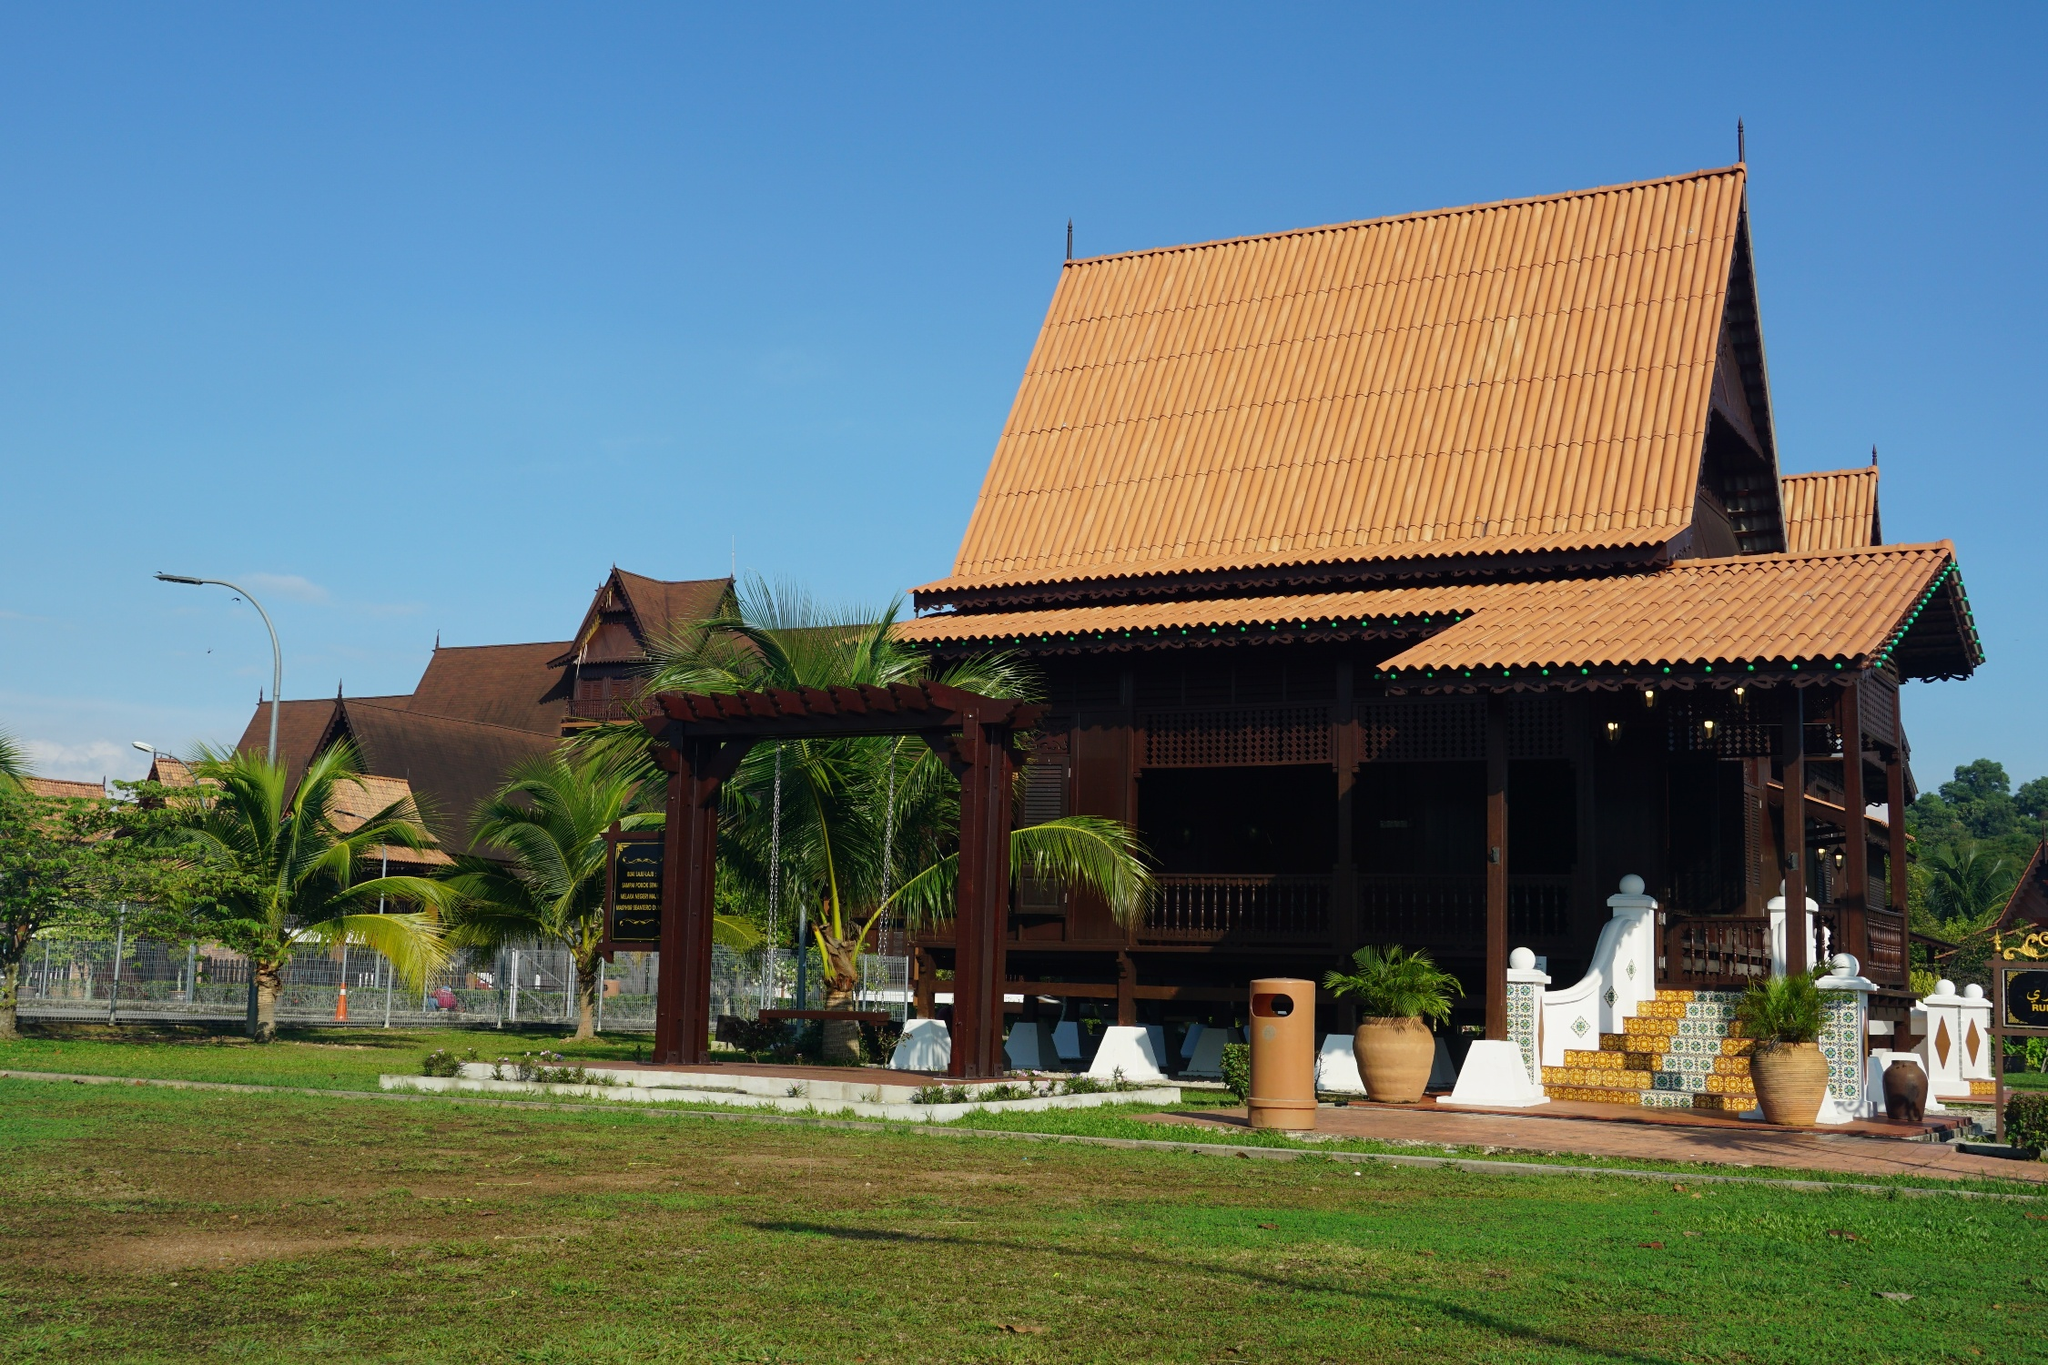If you could spend a day at this location, what would you do? Spending a day at this location would be an absolute delight! I would start my morning by exploring the house, captivated by its architectural beauty and intricate details. After that, I would enjoy a leisurely stroll around the lush garden, admiring the tropical plants and the soothing sounds of nature.

For lunch, I would have a picnic on the pristine lawn, savoring delicious Thai cuisine while basking in the sun and gentle breeze. In the afternoon, I might relax on the porch with a good book, immersing myself in the tranquil environment.

As the day comes to a close, I would take a walk among the swaying palm trees, reflecting on the serene beauty of the setting. The sunset would paint the sky in vibrant hues, creating a perfect ending to a peaceful and refreshing day. How might this house appear in a historical film? In a historical film, this traditional Thai house would serve as a stunning and authentic backdrop, adding depth and realism to the narrative. The film might depict life in a rural village, focusing on the day-to-day activities of its inhabitants. The house's architecture, with its elevated structure and steeply pitched roof, would be central to scenes depicting cultural traditions, family gatherings, and community events.

Intricate wooden carvings would be showcased in moments that highlight Thai craftsmanship, perhaps in a scene where artisans are seen working meticulously on their art. The lush green lawn and surrounding palm trees could serve as settings for key plot points, whether it's a joyous celebration or a poignant moment of reflection. The house, with its rich cultural and historical significance, would enhance the film's authenticity and visual appeal, transporting viewers back in time to experience the beauty and essence of traditional Thai life. What activities might the residents of this house enjoy on a typical day? The residents of this traditional Thai house likely enjoy a variety of activities that connect them with their culture and environment. Their day might begin with a quiet morning ritual, offering prayers and preparing traditional Thai breakfast using fresh, locally sourced ingredients. This is followed by tending to the garden, ensuring the plants are well-cared for amid the tropical ambiance.

In the late morning and afternoon, the family might engage in crafting activities such as weaving or wood carving, reflecting the rich traditions of Thai artistry. Children might play in the spacious lawn, perhaps gathering under the shade of the palm trees for games or stories.

Meals would be a central part of daily life, with everyone coming together to prepare and enjoy dishes that are rich in flavors and heritage. Evenings could be spent on the porch, sharing stories and experiences or simply enjoying the serene surroundings. Cultural practices like dance or music might also play a role in their daily activities, bringing the traditions and spirit of their heritage to life. 